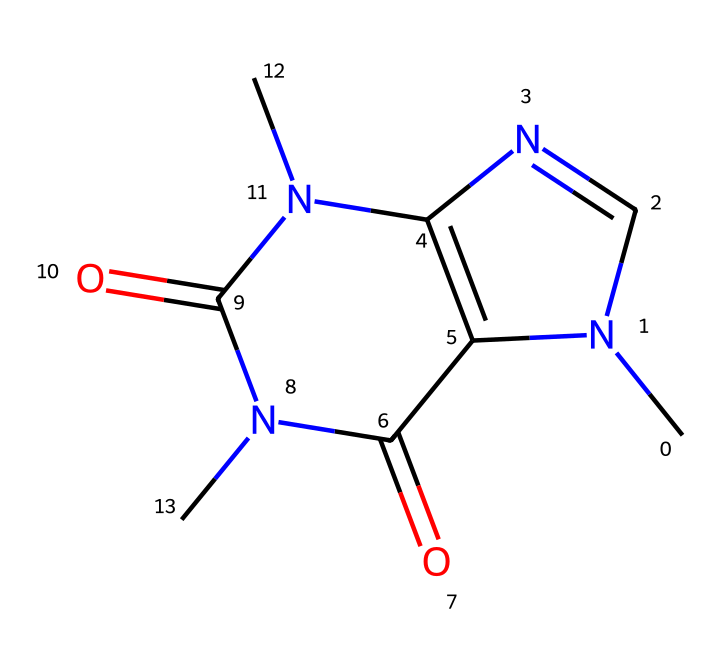How many nitrogen atoms are present in this caffeine structure? The SMILES representation contains CN1C and N(C(=O)N2C), indicating the presence of nitrogen atoms. Counting these, there are four nitrogen atoms in the structure.
Answer: four What functional groups are found in caffeine? In the chemical structure, there are amide groups (C(=O)N), which are part of the nitrogen-containing atoms. This indicates the presence of two amide functional groups.
Answer: two amide groups What is the molecular formula of caffeine? To derive the molecular formula, the number of each atom type is counted as represented in the molecule: Carbon (C), Hydrogen (H), Nitrogen (N), and Oxygen (O). The counted atoms yield the formula C8H10N4O2.
Answer: C8H10N4O2 Is caffeine a stimulant? The chemical structure of caffeine, characterized as a xanthine alkaloid, is widely recognized for its stimulating effects in humans. Evidence from research supports its classification as a stimulant.
Answer: yes How does caffeine's structure contribute to its solubility in water? Caffeine's structure contains polar functional groups, particularly the nitrogen atoms in the amide groups, which enhance its ability to interact with and dissolve in water due to hydrogen bonding.
Answer: polar functional groups What type of molecule is caffeine classified as? Based on its chemical structure and presence of nitrogen, caffeine is classified as an alkaloid, which are complex nitrogen-containing compounds often derived from plants and known for their physiological effects.
Answer: alkaloid How many rings are present in the caffeine structure? Analyzing the structure, there are two fused ring systems indicated by the cyclic parts of the SMILES notation. This identifies that caffeine has two rings in its structure.
Answer: two rings 